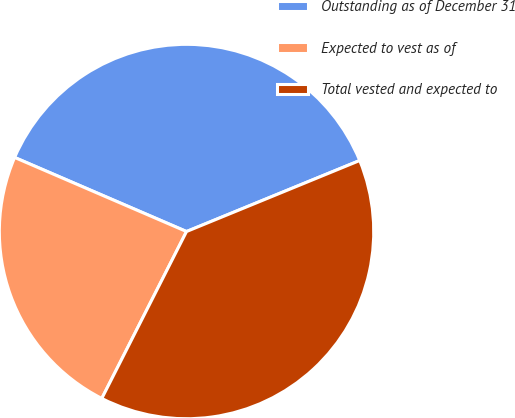Convert chart to OTSL. <chart><loc_0><loc_0><loc_500><loc_500><pie_chart><fcel>Outstanding as of December 31<fcel>Expected to vest as of<fcel>Total vested and expected to<nl><fcel>37.33%<fcel>24.0%<fcel>38.67%<nl></chart> 